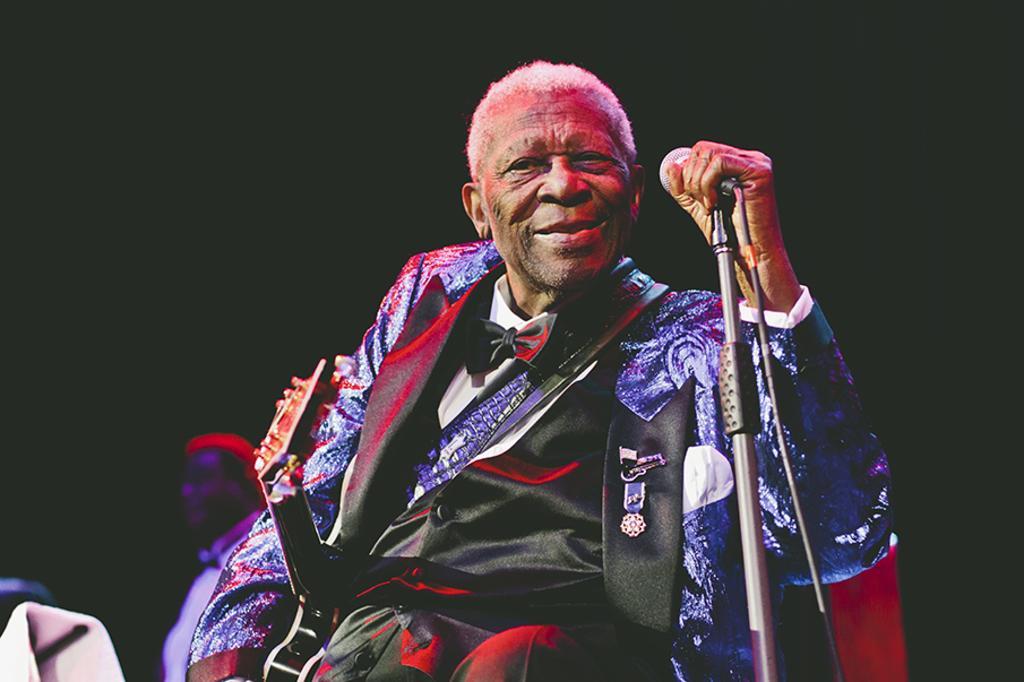Can you describe this image briefly? In this picture we see an old man holding a mike and looking at someone. 